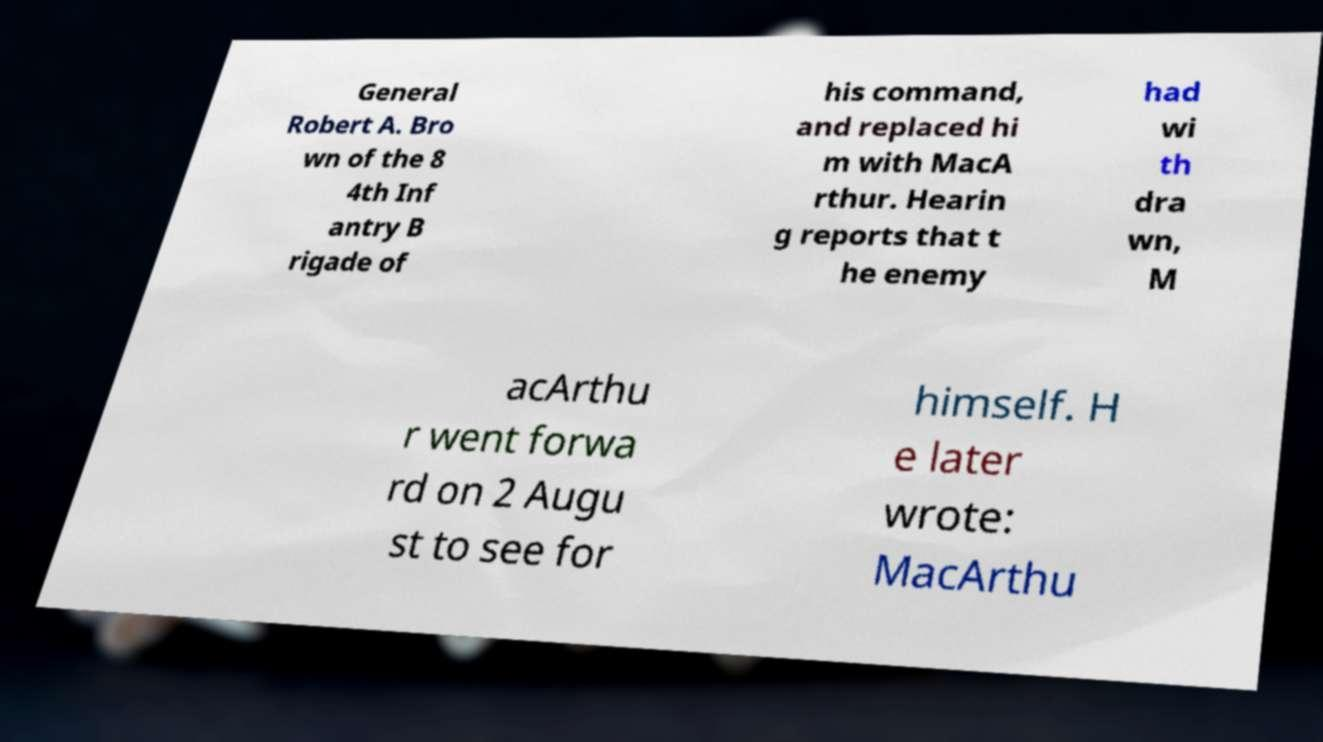There's text embedded in this image that I need extracted. Can you transcribe it verbatim? General Robert A. Bro wn of the 8 4th Inf antry B rigade of his command, and replaced hi m with MacA rthur. Hearin g reports that t he enemy had wi th dra wn, M acArthu r went forwa rd on 2 Augu st to see for himself. H e later wrote: MacArthu 